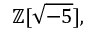Convert formula to latex. <formula><loc_0><loc_0><loc_500><loc_500>\mathbb { Z } [ { \sqrt { - 5 } } ] ,</formula> 